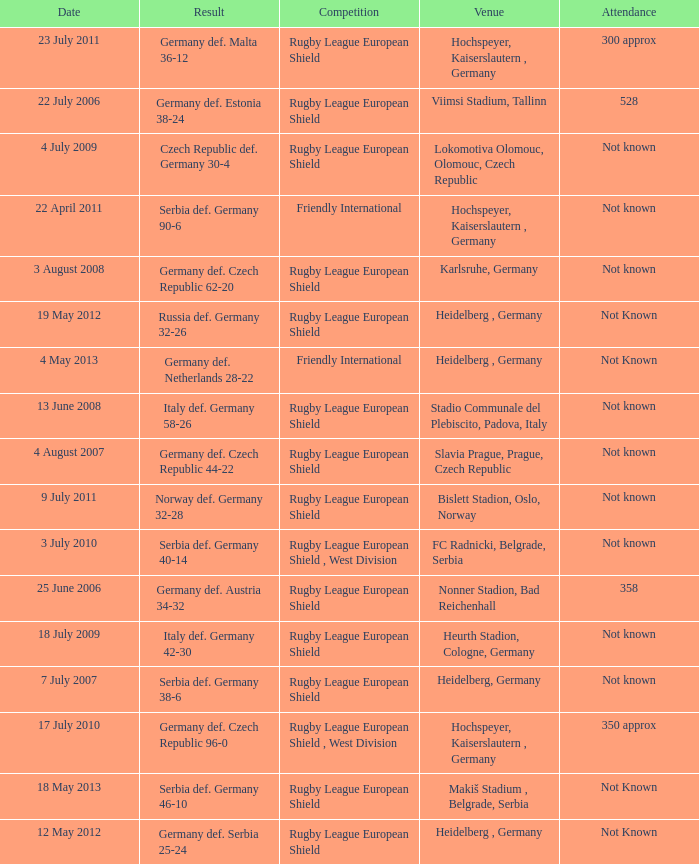Help me parse the entirety of this table. {'header': ['Date', 'Result', 'Competition', 'Venue', 'Attendance'], 'rows': [['23 July 2011', 'Germany def. Malta 36-12', 'Rugby League European Shield', 'Hochspeyer, Kaiserslautern , Germany', '300 approx'], ['22 July 2006', 'Germany def. Estonia 38-24', 'Rugby League European Shield', 'Viimsi Stadium, Tallinn', '528'], ['4 July 2009', 'Czech Republic def. Germany 30-4', 'Rugby League European Shield', 'Lokomotiva Olomouc, Olomouc, Czech Republic', 'Not known'], ['22 April 2011', 'Serbia def. Germany 90-6', 'Friendly International', 'Hochspeyer, Kaiserslautern , Germany', 'Not known'], ['3 August 2008', 'Germany def. Czech Republic 62-20', 'Rugby League European Shield', 'Karlsruhe, Germany', 'Not known'], ['19 May 2012', 'Russia def. Germany 32-26', 'Rugby League European Shield', 'Heidelberg , Germany', 'Not Known'], ['4 May 2013', 'Germany def. Netherlands 28-22', 'Friendly International', 'Heidelberg , Germany', 'Not Known'], ['13 June 2008', 'Italy def. Germany 58-26', 'Rugby League European Shield', 'Stadio Communale del Plebiscito, Padova, Italy', 'Not known'], ['4 August 2007', 'Germany def. Czech Republic 44-22', 'Rugby League European Shield', 'Slavia Prague, Prague, Czech Republic', 'Not known'], ['9 July 2011', 'Norway def. Germany 32-28', 'Rugby League European Shield', 'Bislett Stadion, Oslo, Norway', 'Not known'], ['3 July 2010', 'Serbia def. Germany 40-14', 'Rugby League European Shield , West Division', 'FC Radnicki, Belgrade, Serbia', 'Not known'], ['25 June 2006', 'Germany def. Austria 34-32', 'Rugby League European Shield', 'Nonner Stadion, Bad Reichenhall', '358'], ['18 July 2009', 'Italy def. Germany 42-30', 'Rugby League European Shield', 'Heurth Stadion, Cologne, Germany', 'Not known'], ['7 July 2007', 'Serbia def. Germany 38-6', 'Rugby League European Shield', 'Heidelberg, Germany', 'Not known'], ['17 July 2010', 'Germany def. Czech Republic 96-0', 'Rugby League European Shield , West Division', 'Hochspeyer, Kaiserslautern , Germany', '350 approx'], ['18 May 2013', 'Serbia def. Germany 46-10', 'Rugby League European Shield', 'Makiš Stadium , Belgrade, Serbia', 'Not Known'], ['12 May 2012', 'Germany def. Serbia 25-24', 'Rugby League European Shield', 'Heidelberg , Germany', 'Not Known']]} For the game with 528 attendance, what was the result? Germany def. Estonia 38-24. 